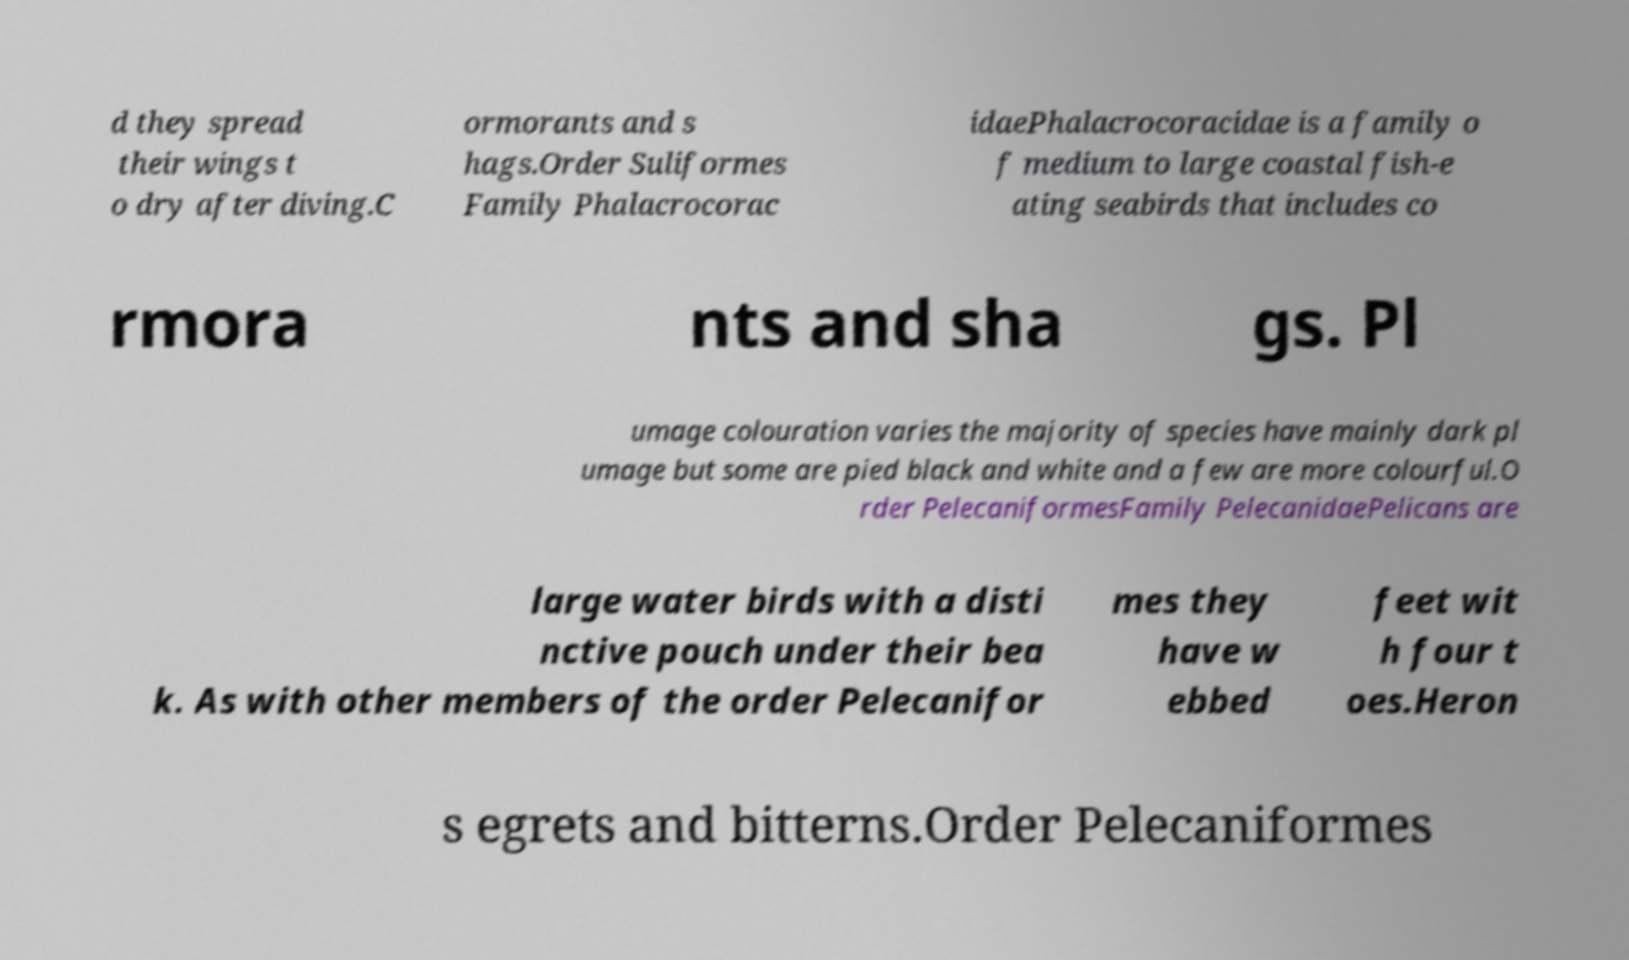Please read and relay the text visible in this image. What does it say? d they spread their wings t o dry after diving.C ormorants and s hags.Order Suliformes Family Phalacrocorac idaePhalacrocoracidae is a family o f medium to large coastal fish-e ating seabirds that includes co rmora nts and sha gs. Pl umage colouration varies the majority of species have mainly dark pl umage but some are pied black and white and a few are more colourful.O rder PelecaniformesFamily PelecanidaePelicans are large water birds with a disti nctive pouch under their bea k. As with other members of the order Pelecanifor mes they have w ebbed feet wit h four t oes.Heron s egrets and bitterns.Order Pelecaniformes 